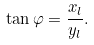Convert formula to latex. <formula><loc_0><loc_0><loc_500><loc_500>\tan \varphi = \frac { x _ { l } } { y _ { l } } .</formula> 